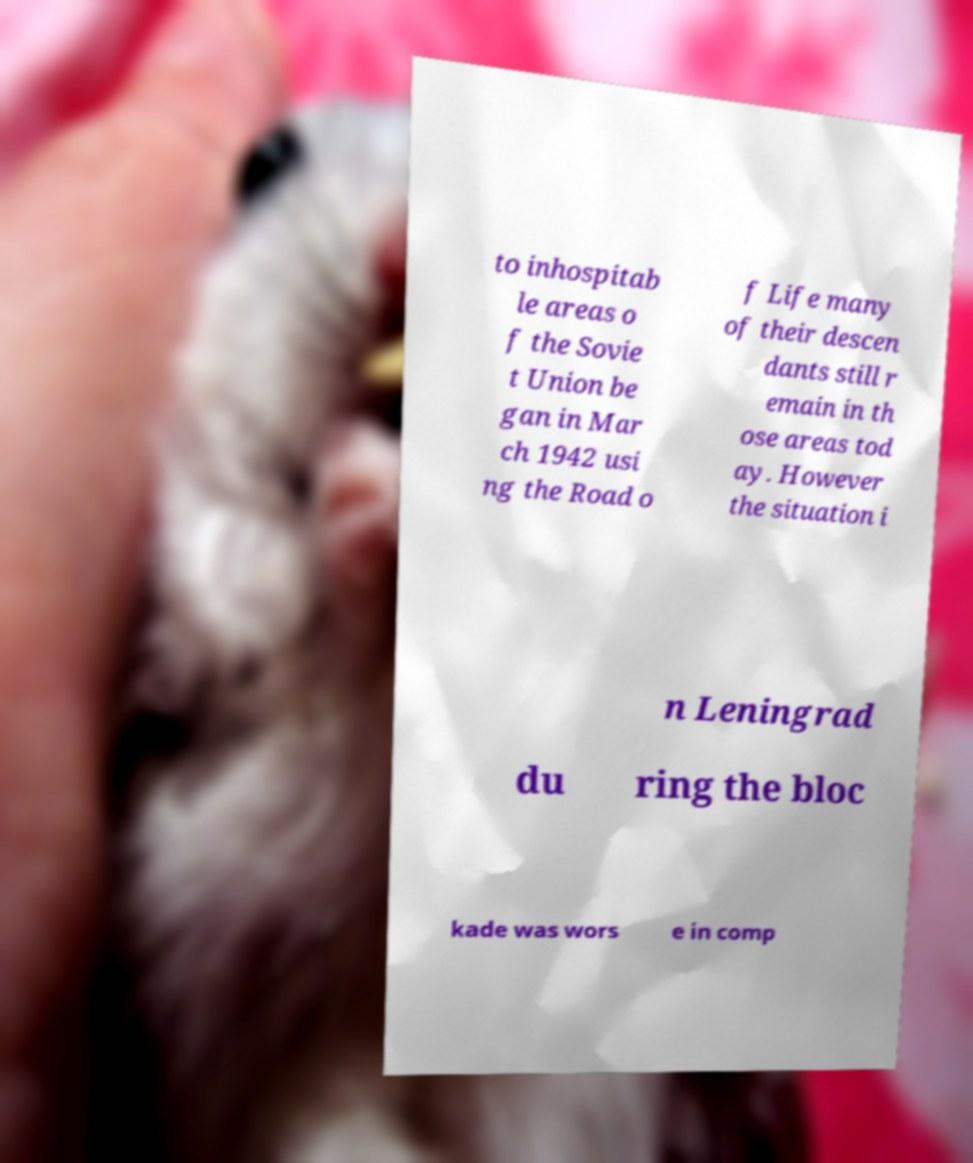Could you extract and type out the text from this image? to inhospitab le areas o f the Sovie t Union be gan in Mar ch 1942 usi ng the Road o f Life many of their descen dants still r emain in th ose areas tod ay. However the situation i n Leningrad du ring the bloc kade was wors e in comp 